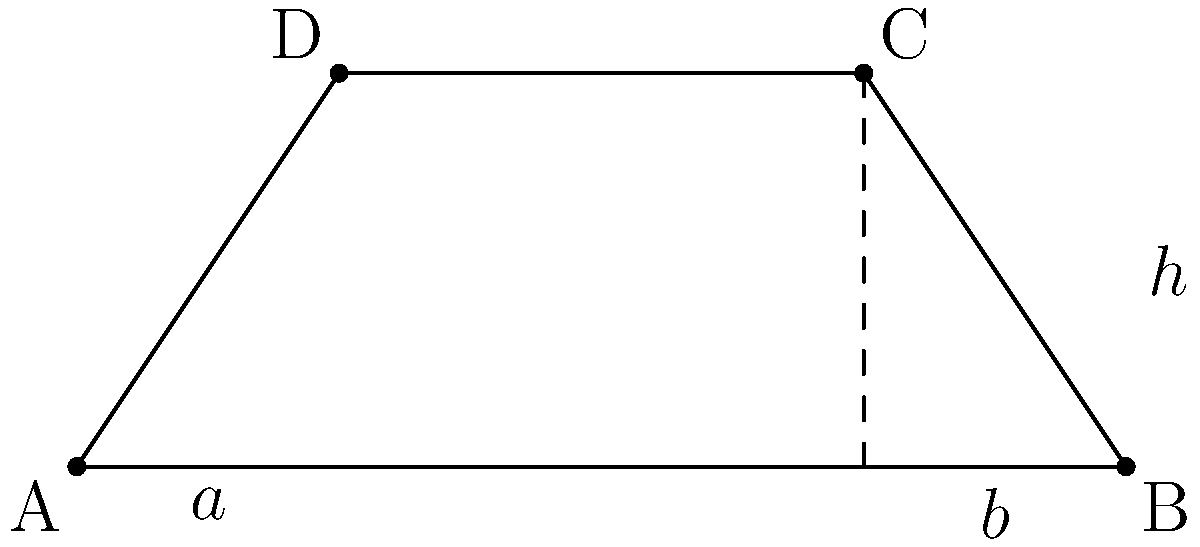In accordance with Swiss precision standards, consider a trapezoid ABCD with parallel sides $a = 6$ cm and $b = 4$ cm, and a height $h = 3$ cm. Calculate the perimeter of the trapezoid to the nearest millimeter. To calculate the perimeter of the trapezoid, we need to determine the lengths of all four sides and sum them up. Let's proceed step-by-step:

1) We already know the lengths of the parallel sides:
   $AB = b = 4$ cm
   $DC = a = 6$ cm

2) To find the lengths of AD and BC, we can use the Pythagorean theorem:
   Let x be the difference between half of (a-b) and the length of AD or BC.
   
   $x = \frac{a-b}{2} = \frac{6-4}{2} = 1$ cm

3) Now we can calculate the length of AD (which is equal to BC) using the Pythagorean theorem:

   $AD^2 = x^2 + h^2$
   $AD^2 = 1^2 + 3^2 = 1 + 9 = 10$
   $AD = \sqrt{10}$ cm

4) The perimeter is the sum of all sides:
   $P = a + b + 2\sqrt{10}$
   $P = 6 + 4 + 2\sqrt{10}$
   $P = 10 + 2\sqrt{10}$ cm

5) Calculate the value:
   $P = 10 + 2 * 3.162277... = 16.324555...$ cm

6) Rounding to the nearest millimeter as per Swiss precision standards:
   $P \approx 16.325$ cm
Answer: $16.325$ cm 